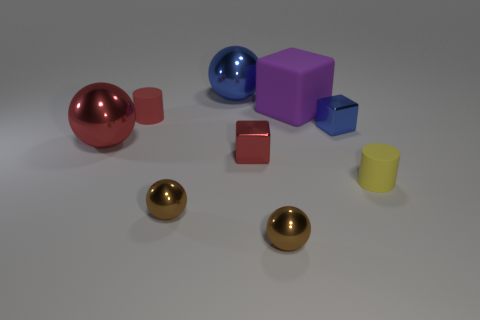Subtract all gray balls. Subtract all blue cylinders. How many balls are left? 4 Add 1 big blue spheres. How many objects exist? 10 Subtract all balls. How many objects are left? 5 Subtract 1 red cubes. How many objects are left? 8 Subtract all big yellow spheres. Subtract all red cylinders. How many objects are left? 8 Add 6 purple matte cubes. How many purple matte cubes are left? 7 Add 2 shiny objects. How many shiny objects exist? 8 